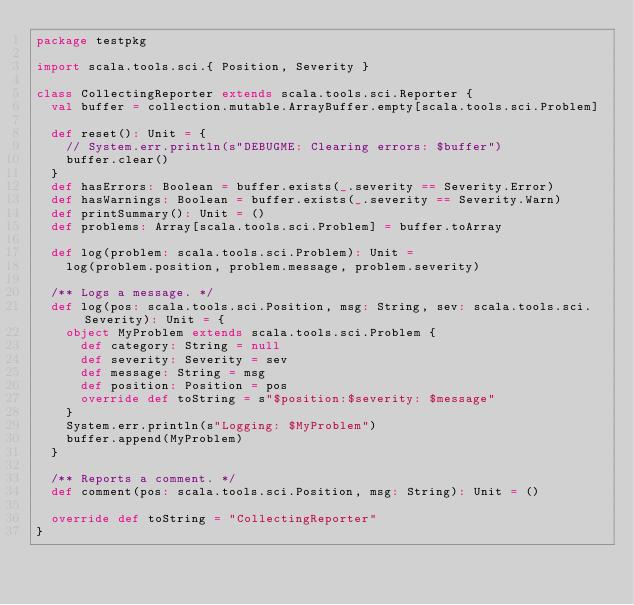<code> <loc_0><loc_0><loc_500><loc_500><_Scala_>package testpkg

import scala.tools.sci.{ Position, Severity }

class CollectingReporter extends scala.tools.sci.Reporter {
  val buffer = collection.mutable.ArrayBuffer.empty[scala.tools.sci.Problem]

  def reset(): Unit = {
    // System.err.println(s"DEBUGME: Clearing errors: $buffer")
    buffer.clear()
  }
  def hasErrors: Boolean = buffer.exists(_.severity == Severity.Error)
  def hasWarnings: Boolean = buffer.exists(_.severity == Severity.Warn)
  def printSummary(): Unit = ()
  def problems: Array[scala.tools.sci.Problem] = buffer.toArray

  def log(problem: scala.tools.sci.Problem): Unit =
    log(problem.position, problem.message, problem.severity)

  /** Logs a message. */
  def log(pos: scala.tools.sci.Position, msg: String, sev: scala.tools.sci.Severity): Unit = {
    object MyProblem extends scala.tools.sci.Problem {
      def category: String = null
      def severity: Severity = sev
      def message: String = msg
      def position: Position = pos
      override def toString = s"$position:$severity: $message"
    }
    System.err.println(s"Logging: $MyProblem")
    buffer.append(MyProblem)
  }

  /** Reports a comment. */
  def comment(pos: scala.tools.sci.Position, msg: String): Unit = ()

  override def toString = "CollectingReporter"
}
</code> 